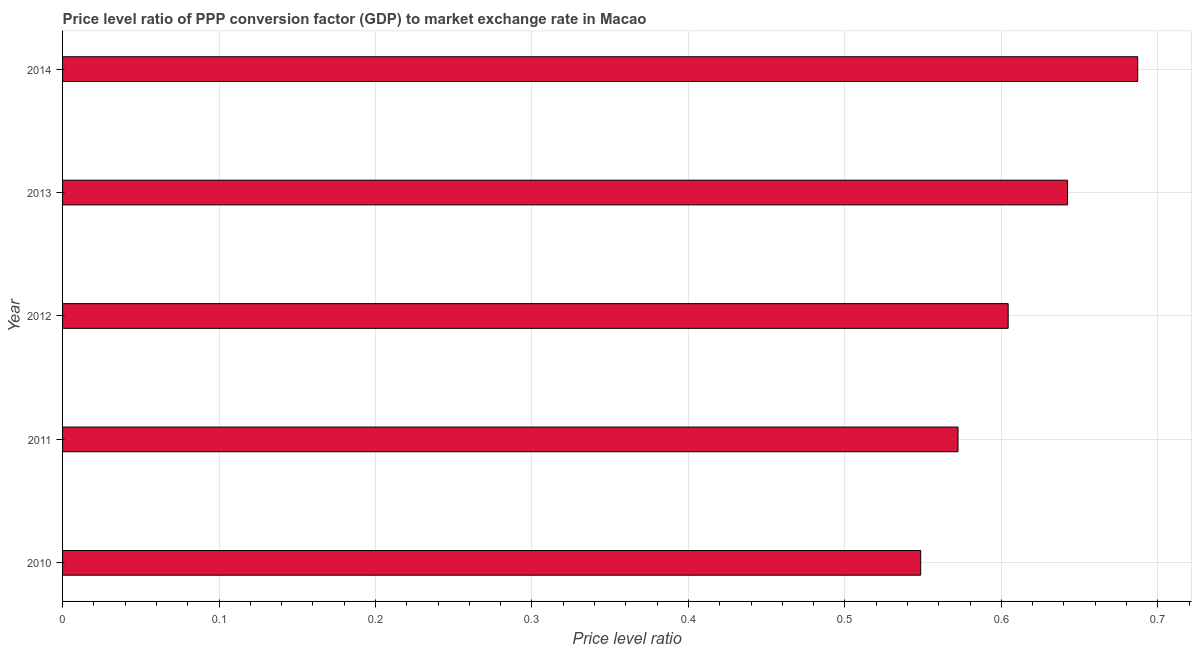Does the graph contain grids?
Provide a short and direct response. Yes. What is the title of the graph?
Give a very brief answer. Price level ratio of PPP conversion factor (GDP) to market exchange rate in Macao. What is the label or title of the X-axis?
Keep it short and to the point. Price level ratio. What is the price level ratio in 2010?
Offer a very short reply. 0.55. Across all years, what is the maximum price level ratio?
Offer a very short reply. 0.69. Across all years, what is the minimum price level ratio?
Offer a terse response. 0.55. In which year was the price level ratio maximum?
Offer a very short reply. 2014. What is the sum of the price level ratio?
Ensure brevity in your answer.  3.05. What is the difference between the price level ratio in 2010 and 2014?
Provide a short and direct response. -0.14. What is the average price level ratio per year?
Offer a very short reply. 0.61. What is the median price level ratio?
Ensure brevity in your answer.  0.6. In how many years, is the price level ratio greater than 0.06 ?
Give a very brief answer. 5. What is the ratio of the price level ratio in 2011 to that in 2014?
Keep it short and to the point. 0.83. Is the price level ratio in 2010 less than that in 2014?
Keep it short and to the point. Yes. Is the difference between the price level ratio in 2010 and 2013 greater than the difference between any two years?
Ensure brevity in your answer.  No. What is the difference between the highest and the second highest price level ratio?
Your answer should be very brief. 0.04. What is the difference between the highest and the lowest price level ratio?
Offer a terse response. 0.14. How many bars are there?
Offer a very short reply. 5. Are all the bars in the graph horizontal?
Provide a succinct answer. Yes. How many years are there in the graph?
Your answer should be very brief. 5. What is the Price level ratio of 2010?
Your response must be concise. 0.55. What is the Price level ratio in 2011?
Provide a short and direct response. 0.57. What is the Price level ratio of 2012?
Your answer should be compact. 0.6. What is the Price level ratio of 2013?
Offer a very short reply. 0.64. What is the Price level ratio of 2014?
Your answer should be very brief. 0.69. What is the difference between the Price level ratio in 2010 and 2011?
Your answer should be compact. -0.02. What is the difference between the Price level ratio in 2010 and 2012?
Offer a terse response. -0.06. What is the difference between the Price level ratio in 2010 and 2013?
Offer a very short reply. -0.09. What is the difference between the Price level ratio in 2010 and 2014?
Keep it short and to the point. -0.14. What is the difference between the Price level ratio in 2011 and 2012?
Make the answer very short. -0.03. What is the difference between the Price level ratio in 2011 and 2013?
Provide a short and direct response. -0.07. What is the difference between the Price level ratio in 2011 and 2014?
Offer a terse response. -0.11. What is the difference between the Price level ratio in 2012 and 2013?
Provide a short and direct response. -0.04. What is the difference between the Price level ratio in 2012 and 2014?
Offer a very short reply. -0.08. What is the difference between the Price level ratio in 2013 and 2014?
Offer a terse response. -0.04. What is the ratio of the Price level ratio in 2010 to that in 2011?
Keep it short and to the point. 0.96. What is the ratio of the Price level ratio in 2010 to that in 2012?
Your answer should be compact. 0.91. What is the ratio of the Price level ratio in 2010 to that in 2013?
Keep it short and to the point. 0.85. What is the ratio of the Price level ratio in 2010 to that in 2014?
Offer a terse response. 0.8. What is the ratio of the Price level ratio in 2011 to that in 2012?
Your response must be concise. 0.95. What is the ratio of the Price level ratio in 2011 to that in 2013?
Keep it short and to the point. 0.89. What is the ratio of the Price level ratio in 2011 to that in 2014?
Provide a succinct answer. 0.83. What is the ratio of the Price level ratio in 2012 to that in 2013?
Your answer should be very brief. 0.94. What is the ratio of the Price level ratio in 2012 to that in 2014?
Offer a very short reply. 0.88. What is the ratio of the Price level ratio in 2013 to that in 2014?
Ensure brevity in your answer.  0.94. 